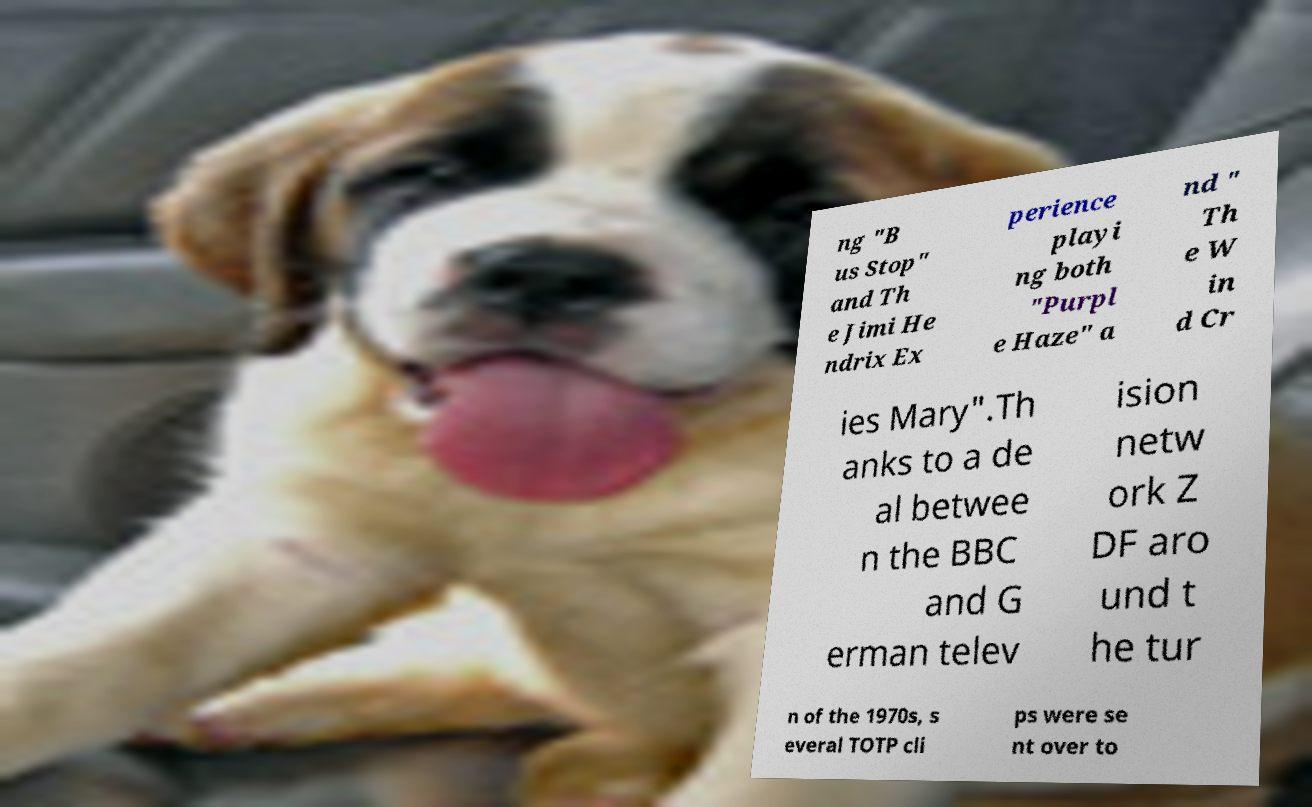I need the written content from this picture converted into text. Can you do that? ng "B us Stop" and Th e Jimi He ndrix Ex perience playi ng both "Purpl e Haze" a nd " Th e W in d Cr ies Mary".Th anks to a de al betwee n the BBC and G erman telev ision netw ork Z DF aro und t he tur n of the 1970s, s everal TOTP cli ps were se nt over to 